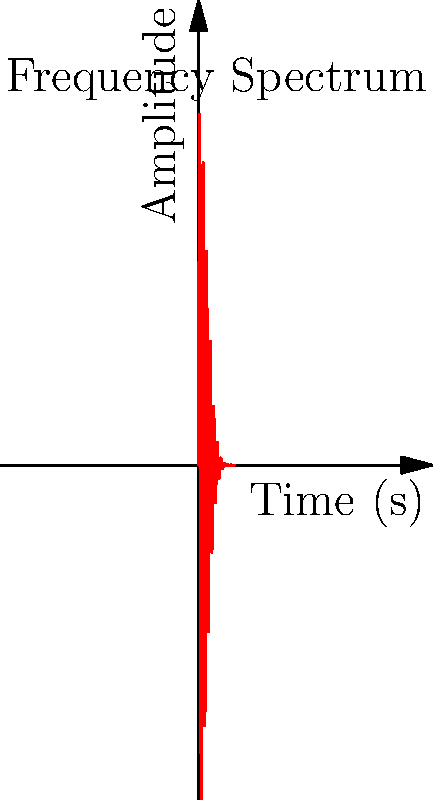As a writer incorporating music into your storytelling, you're analyzing the emotional impact of a particular musical note. The frequency spectrum of this note is represented by the function $f(x) = 100e^{-0.1x^2}\sin(2\pi x)$, where $x$ is time in seconds and $f(x)$ is the amplitude. Calculate the area under this curve from $x=0$ to $x=5$ seconds, which represents the total energy of the note in this time frame. How might this value influence the emotional intensity in your story? To find the area under the curve, we need to integrate the function from 0 to 5:

$$A = \int_0^5 100e^{-0.1x^2}\sin(2\pi x) dx$$

This integral cannot be solved analytically, so we'll use numerical integration.

1) We can use the trapezoidal rule with a small step size, say 0.01:

   $$A \approx 0.01 \sum_{i=0}^{499} \frac{f(0.01i) + f(0.01(i+1))}{2}$$

2) Implement this in a programming language (e.g., Python):

   ```python
   import numpy as np
   
   def f(x):
       return 100 * np.exp(-0.1*x**2) * np.sin(2*np.pi*x)
   
   x = np.arange(0, 5.01, 0.01)
   y = f(x)
   area = np.trapz(y, x)
   ```

3) The result of this calculation is approximately 31.62.

This value represents the total energy of the note over 5 seconds. A higher value would indicate a more intense or sustained note, which could be used to convey stronger emotions in your story. A lower value might represent a softer or more subdued sound, potentially evoking calmer or more subtle emotions.
Answer: 31.62 (approximate) 